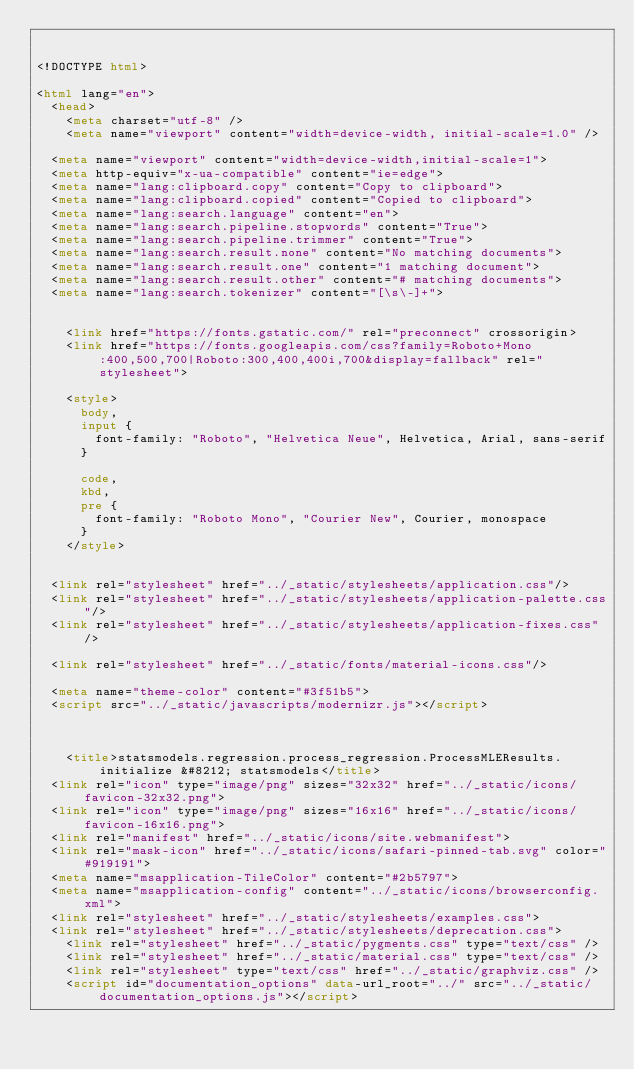Convert code to text. <code><loc_0><loc_0><loc_500><loc_500><_HTML_>

<!DOCTYPE html>

<html lang="en">
  <head>
    <meta charset="utf-8" />
    <meta name="viewport" content="width=device-width, initial-scale=1.0" />
  
  <meta name="viewport" content="width=device-width,initial-scale=1">
  <meta http-equiv="x-ua-compatible" content="ie=edge">
  <meta name="lang:clipboard.copy" content="Copy to clipboard">
  <meta name="lang:clipboard.copied" content="Copied to clipboard">
  <meta name="lang:search.language" content="en">
  <meta name="lang:search.pipeline.stopwords" content="True">
  <meta name="lang:search.pipeline.trimmer" content="True">
  <meta name="lang:search.result.none" content="No matching documents">
  <meta name="lang:search.result.one" content="1 matching document">
  <meta name="lang:search.result.other" content="# matching documents">
  <meta name="lang:search.tokenizer" content="[\s\-]+">

  
    <link href="https://fonts.gstatic.com/" rel="preconnect" crossorigin>
    <link href="https://fonts.googleapis.com/css?family=Roboto+Mono:400,500,700|Roboto:300,400,400i,700&display=fallback" rel="stylesheet">

    <style>
      body,
      input {
        font-family: "Roboto", "Helvetica Neue", Helvetica, Arial, sans-serif
      }

      code,
      kbd,
      pre {
        font-family: "Roboto Mono", "Courier New", Courier, monospace
      }
    </style>
  

  <link rel="stylesheet" href="../_static/stylesheets/application.css"/>
  <link rel="stylesheet" href="../_static/stylesheets/application-palette.css"/>
  <link rel="stylesheet" href="../_static/stylesheets/application-fixes.css"/>
  
  <link rel="stylesheet" href="../_static/fonts/material-icons.css"/>
  
  <meta name="theme-color" content="#3f51b5">
  <script src="../_static/javascripts/modernizr.js"></script>
  
  
  
    <title>statsmodels.regression.process_regression.ProcessMLEResults.initialize &#8212; statsmodels</title>
  <link rel="icon" type="image/png" sizes="32x32" href="../_static/icons/favicon-32x32.png">
  <link rel="icon" type="image/png" sizes="16x16" href="../_static/icons/favicon-16x16.png">
  <link rel="manifest" href="../_static/icons/site.webmanifest">
  <link rel="mask-icon" href="../_static/icons/safari-pinned-tab.svg" color="#919191">
  <meta name="msapplication-TileColor" content="#2b5797">
  <meta name="msapplication-config" content="../_static/icons/browserconfig.xml">
  <link rel="stylesheet" href="../_static/stylesheets/examples.css">
  <link rel="stylesheet" href="../_static/stylesheets/deprecation.css">
    <link rel="stylesheet" href="../_static/pygments.css" type="text/css" />
    <link rel="stylesheet" href="../_static/material.css" type="text/css" />
    <link rel="stylesheet" type="text/css" href="../_static/graphviz.css" />
    <script id="documentation_options" data-url_root="../" src="../_static/documentation_options.js"></script></code> 